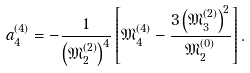Convert formula to latex. <formula><loc_0><loc_0><loc_500><loc_500>a _ { 4 } ^ { ( 4 ) } = - \frac { 1 } { \left ( { \mathfrak { M } } _ { 2 } ^ { ( 2 ) } \right ) ^ { 4 } } \left [ { \mathfrak { M } } _ { 4 } ^ { ( 4 ) } - \frac { 3 \left ( { \mathfrak { M } } _ { 3 } ^ { ( 2 ) } \right ) ^ { 2 } } { { \mathfrak { M } } _ { 2 } ^ { ( 0 ) } } \right ] .</formula> 